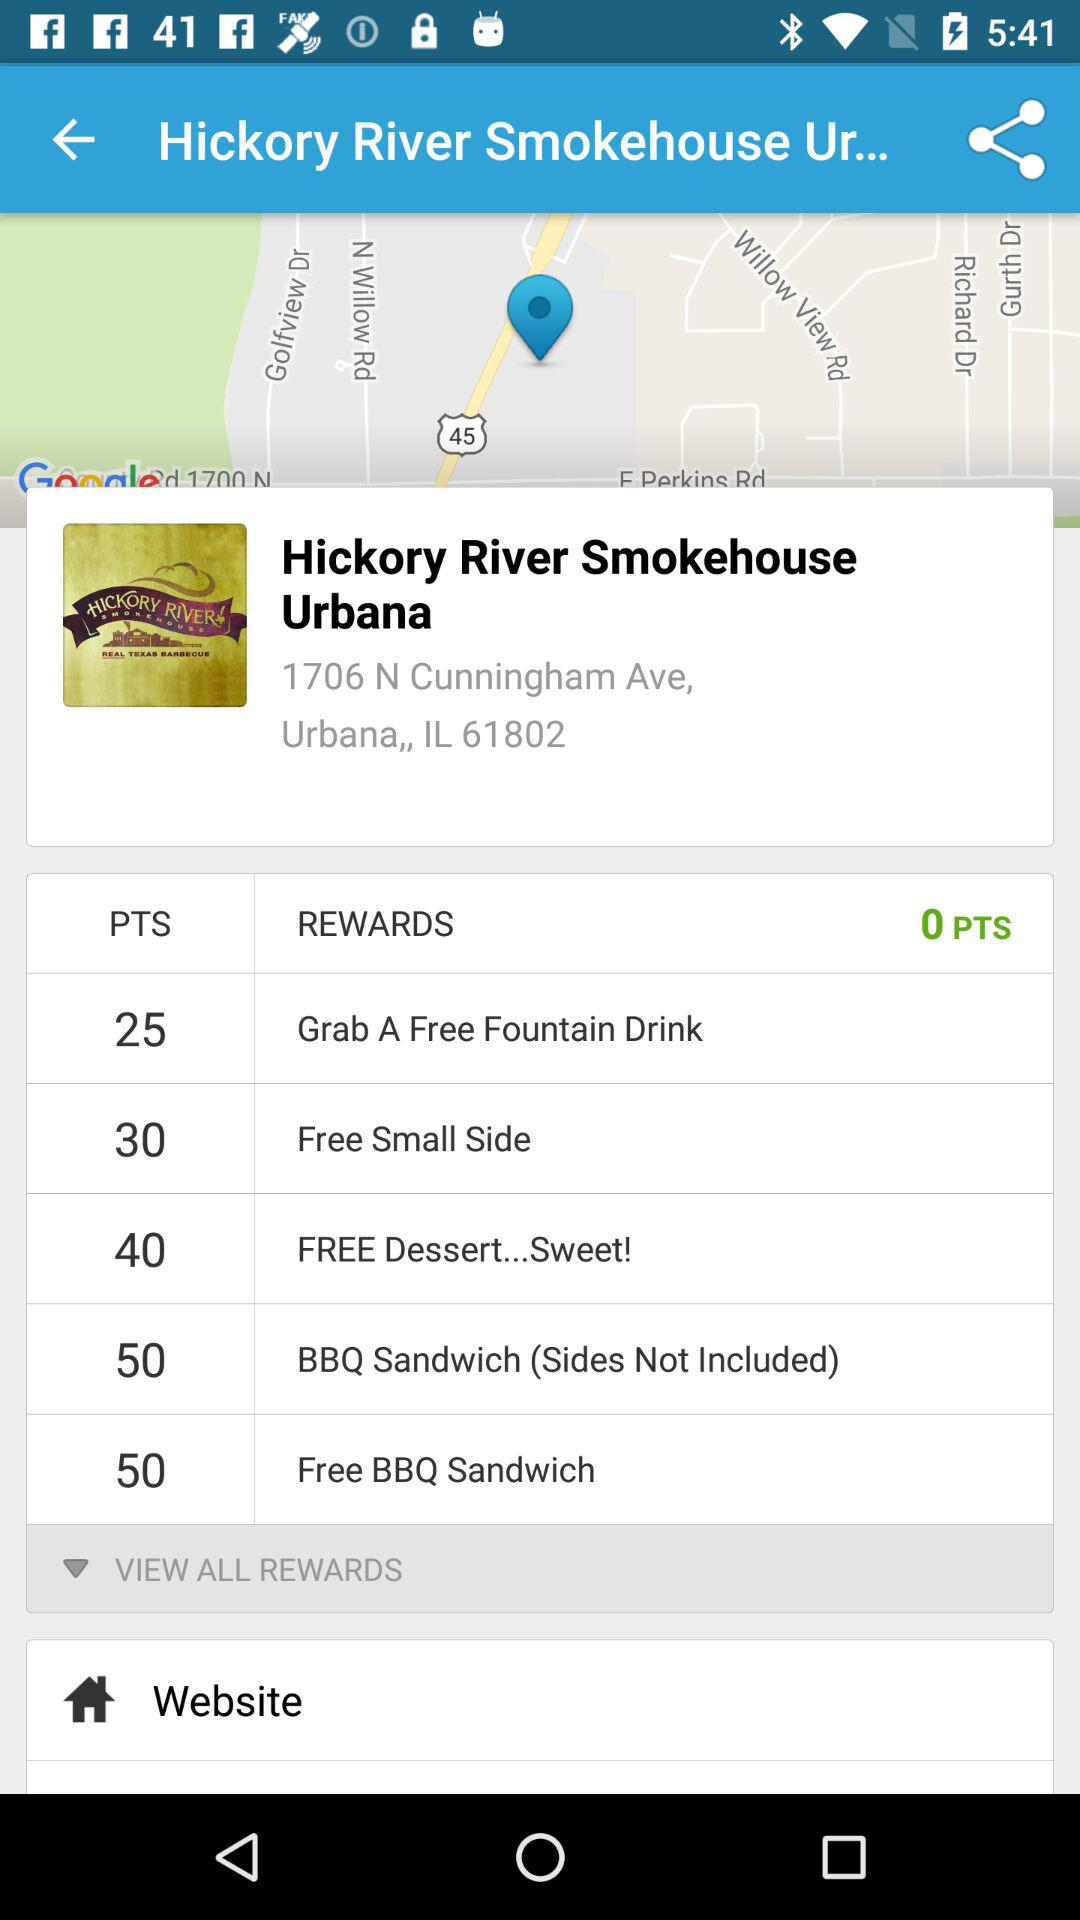Which reward has 30 points? The reward "Free Small Side" has 30 points. 